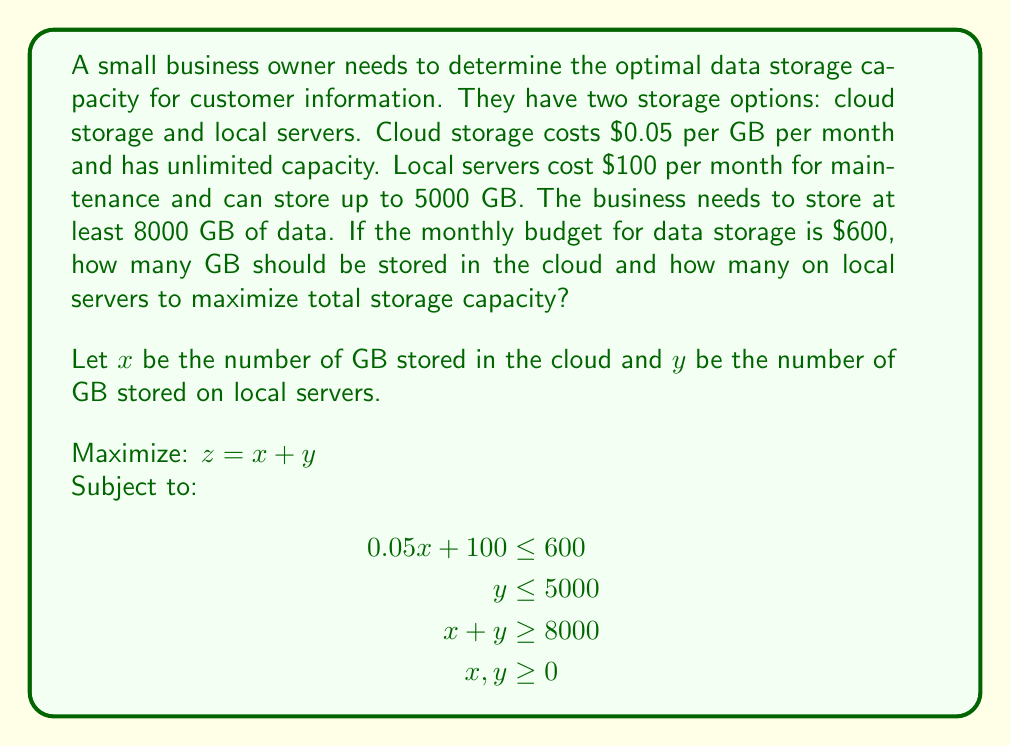Give your solution to this math problem. To solve this linear programming problem, we'll use the graphical method:

1. Plot the constraints:
   - Budget constraint: $0.05x + 100 = 600$ ⇒ $x = 10000$
   - Local server capacity: $y = 5000$
   - Minimum storage requirement: $x + y = 8000$

2. Identify the feasible region:
   The feasible region is bounded by these lines and the non-negativity constraints.

3. Find the corner points of the feasible region:
   A(0, 5000), B(3000, 5000), C(10000, 0)

4. Evaluate the objective function at each corner point:
   A: $z = 0 + 5000 = 5000$
   B: $z = 3000 + 5000 = 8000$
   C: $z = 10000 + 0 = 10000$

5. The maximum value of $z$ occurs at point C(10000, 0).

Therefore, the optimal solution is to store 10000 GB in the cloud and 0 GB on local servers, resulting in a total storage capacity of 10000 GB.

[asy]
import geometry;

size(200);
real xmax = 12000;
real ymax = 6000;

// Axes
draw((0,0)--(xmax,0), arrow=Arrow);
draw((0,0)--(0,ymax), arrow=Arrow);

// Labels
label("Cloud storage (GB)", (xmax,0), E);
label("Local storage (GB)", (0,ymax), N);

// Constraints
draw((10000,0)--(10000,ymax), blue+dashed);
draw((0,5000)--(xmax,5000), red+dashed);
draw((0,8000)--(8000,0), green+dashed);

// Feasible region
fill((0,5000)--(3000,5000)--(10000,0)--(10000,5000)--cycle, lightgray);

// Points
dot((0,5000));
dot((3000,5000));
dot((10000,0));

label("A", (0,5000), NW);
label("B", (3000,5000), N);
label("C", (10000,0), SE);

// Legend
label("Budget constraint", (11000,5500), E, blue);
label("Local server capacity", (11000,5200), E, red);
label("Minimum storage", (11000,4900), E, green);
[/asy]
Answer: The optimal solution is to store 10000 GB in the cloud and 0 GB on local servers, maximizing total storage capacity at 10000 GB. 